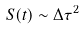<formula> <loc_0><loc_0><loc_500><loc_500>S ( t ) \sim \Delta \tau ^ { 2 }</formula> 